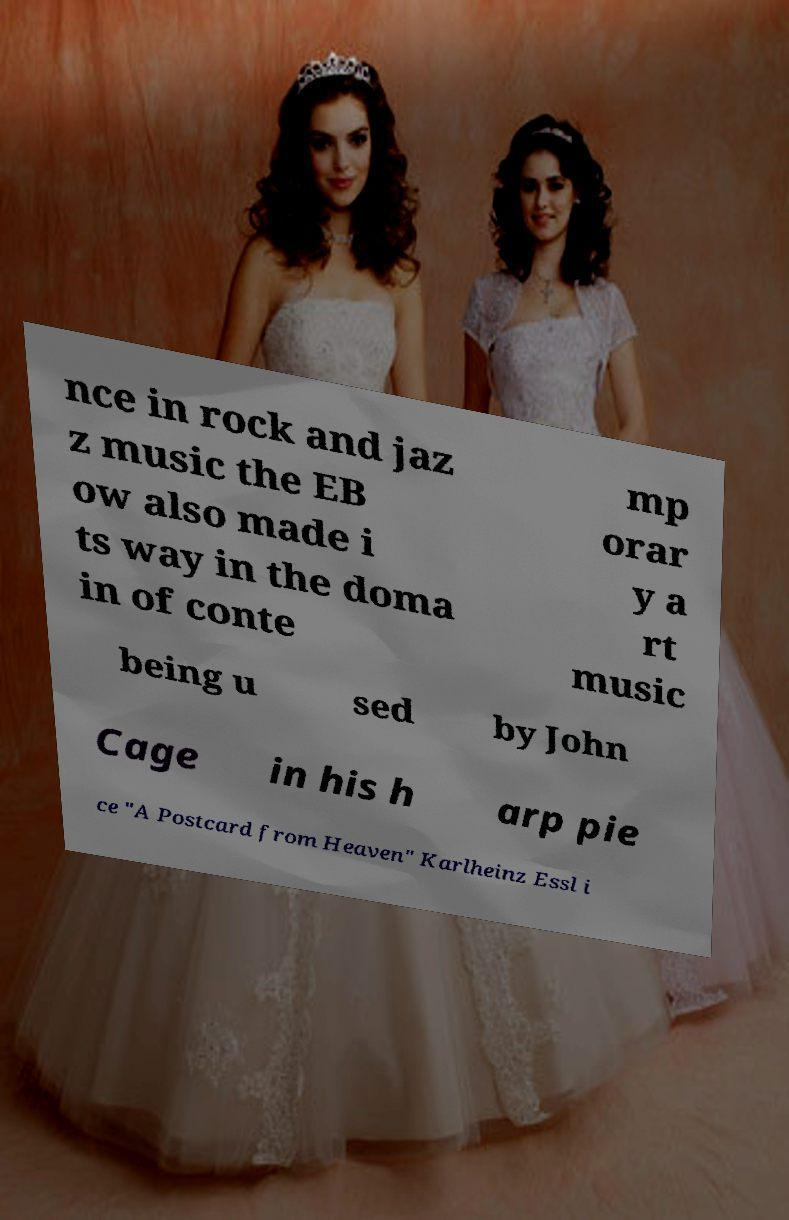Could you extract and type out the text from this image? nce in rock and jaz z music the EB ow also made i ts way in the doma in of conte mp orar y a rt music being u sed by John Cage in his h arp pie ce "A Postcard from Heaven" Karlheinz Essl i 